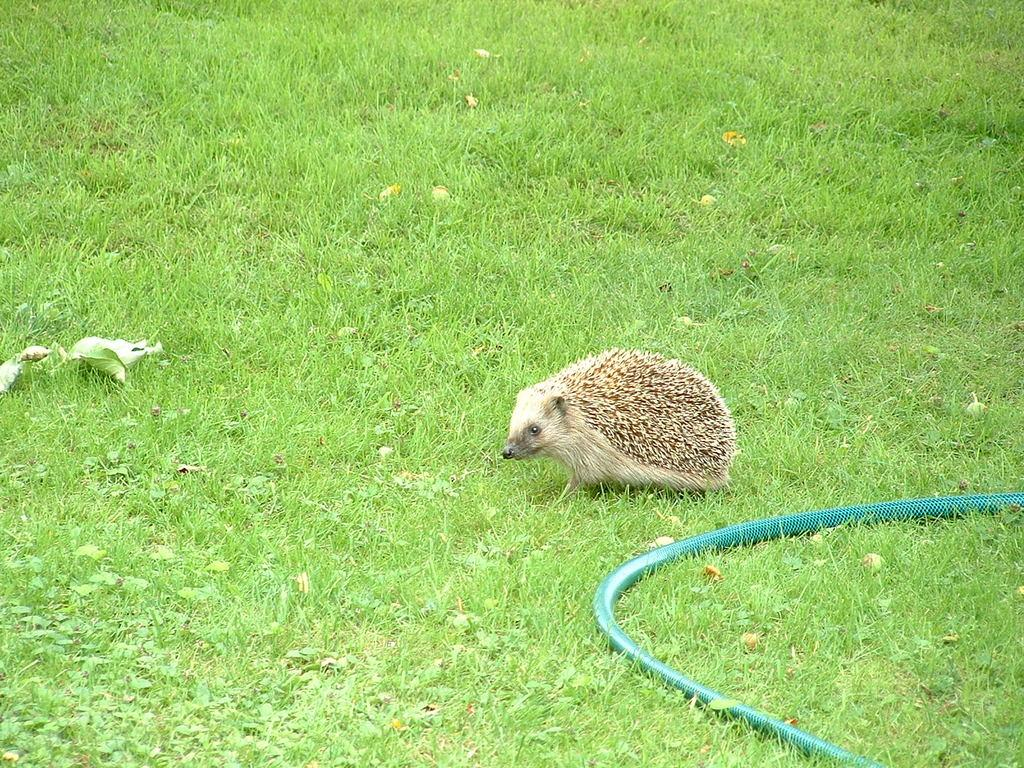What type of animal can be seen in the image? There is a domesticated hedgehog in the image. What is the color of the grass in the image? The grass in the image is green in color. What other object can be seen in the image besides the hedgehog and grass? There is a water pipe in the image. What type of structure is the hedgehog using to tell the time in the image? There is no structure or indication of time in the image; it only features a hedgehog, grass, and a water pipe. 